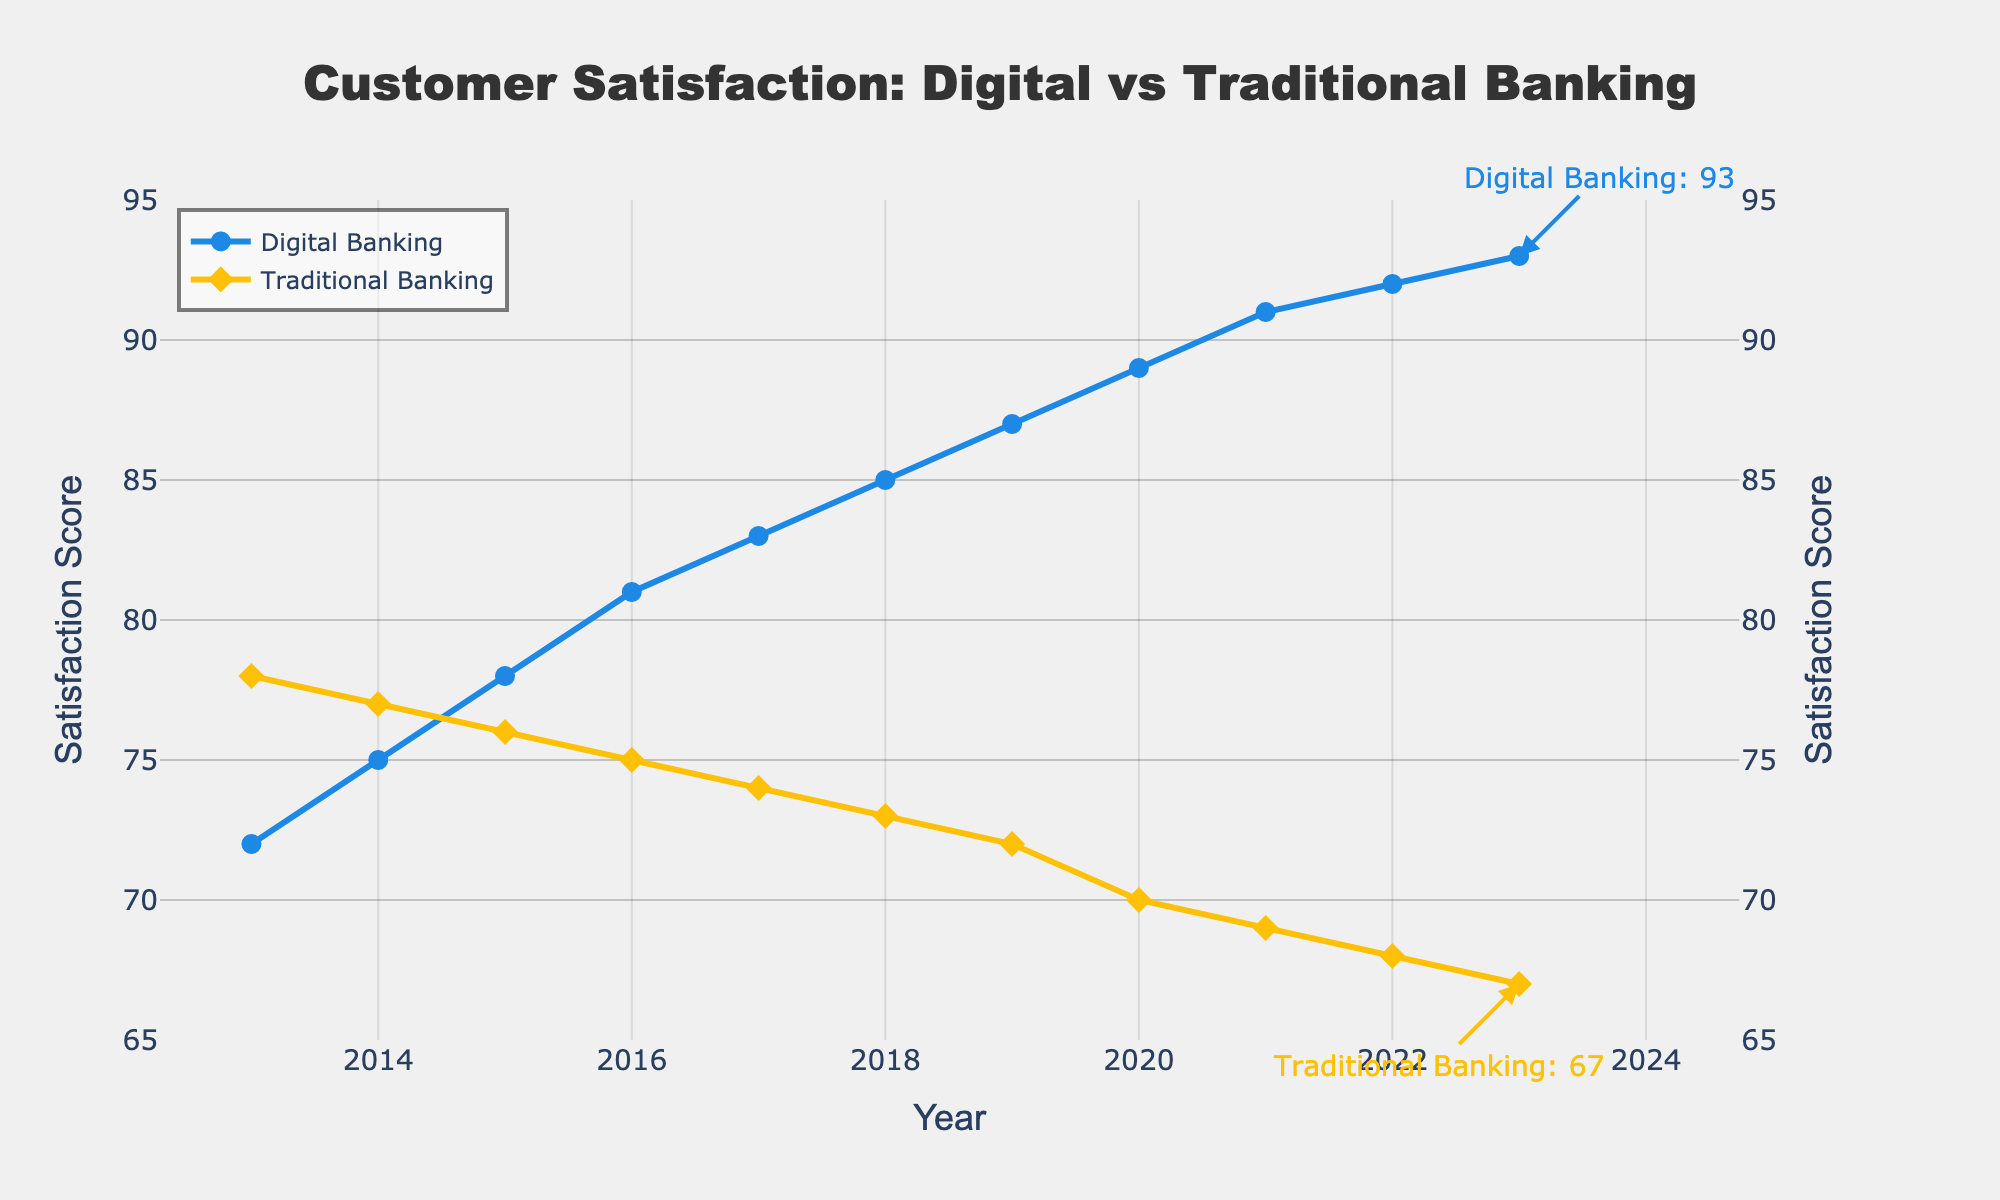What trend do we observe in digital banking satisfaction over the last decade? Starting from 2013 with a score of 72, digital banking satisfaction increases gradually each year and reaches a score of 93 in 2023.
Answer: Increasing Compare the satisfaction scores for digital banking and traditional banking in 2023. Which is higher? In 2023, digital banking satisfaction is 93 while traditional banking satisfaction is 67. Hence, digital banking satisfaction is higher.
Answer: Digital banking Calculate the difference in satisfaction scores between digital banking and traditional banking in 2023. The satisfaction score for digital banking in 2023 is 93, and for traditional banking, it is 67. Therefore, the difference is 93 - 67 = 26.
Answer: 26 What is the overall trend observed in traditional banking satisfaction from 2013 to 2023? In 2013, the traditional banking satisfaction score is 78, which gradually decreases each year to reach 67 in 2023.
Answer: Decreasing In which year did digital banking satisfaction surpass traditional banking satisfaction? Digital banking satisfaction surpassed traditional banking satisfaction in the year 2015, where digital banking had a satisfaction score of 78 compared to traditional banking's 76.
Answer: 2015 Describe the color and shape of the markers used to represent traditional banking satisfaction. Traditional banking satisfaction markers are represented by yellow diamond shapes.
Answer: Yellow diamonds How much did the digital banking satisfaction score increase from 2018 to 2020? In 2018, the digital banking satisfaction score is 85 and in 2020, it is 89. The increase is 89 - 85 = 4.
Answer: 4 What annotation is provided for the 2023 digital banking satisfaction score? The annotation for the 2023 digital banking satisfaction score is "Digital Banking: 93" with an arrow pointing to the score marker.
Answer: "Digital Banking: 93" Is the trend line for traditional banking satisfaction increasing, decreasing, or stable? The trend line for traditional banking satisfaction is decreasing from 2013 to 2023.
Answer: Decreasing 